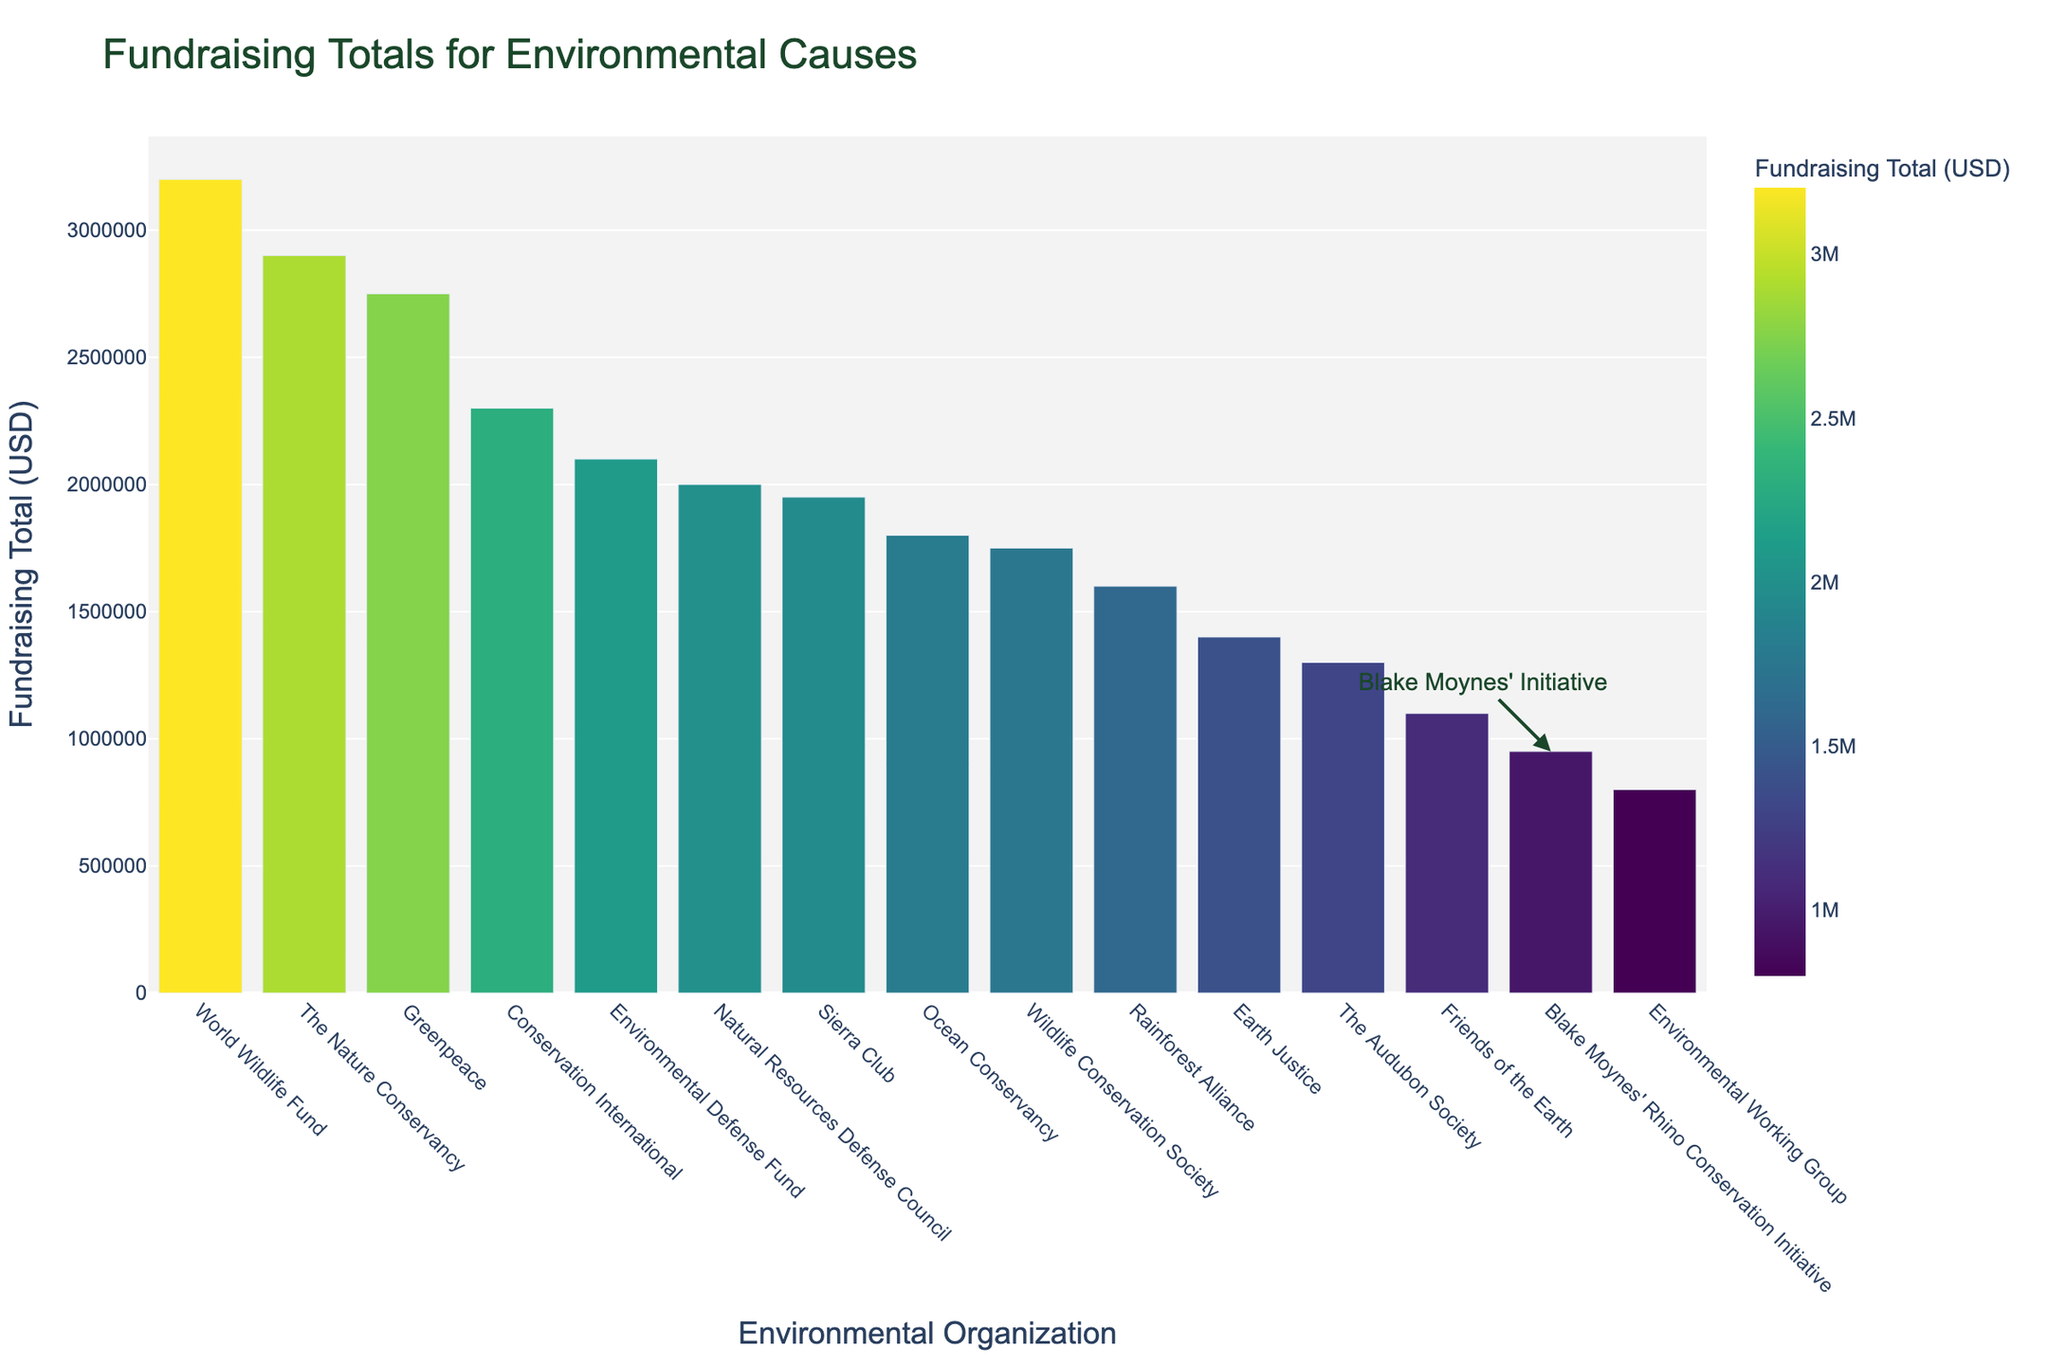Which organization has the highest fundraising total? The highest fundraising total is visually indicated by the tallest bar in the chart. The World Wildlife Fund has the tallest bar.
Answer: World Wildlife Fund Which organization has the lowest fundraising total? The lowest fundraising total is visually indicated by the shortest bar in the chart. The Environmental Working Group has the shortest bar.
Answer: Environmental Working Group What is the total fundraising amount for the top three organizations combined? Sum the fundraising totals of Greenpeace, World Wildlife Fund, and The Nature Conservancy. 2,750,000 + 3,200,000 + 2,900,000 = 8,850,000.
Answer: 8,850,000 How much more did the World Wildlife Fund raise compared to Earth Justice? Subtract Earth Justice’s total from World Wildlife Fund’s total. 3,200,000 - 1,400,000 = 1,800,000.
Answer: 1,800,000 Which organization is just above Blake Moynes' Rhino Conservation Initiative in fundraising totals? Look for the organization that has the next higher bar above Blake Moynes' Rhino Conservation Initiative. Friends of the Earth is just above it.
Answer: Friends of the Earth How much did Conservation International raise compared to the combined total of Ocean Conservancy and Rainforest Alliance? Add Ocean Conservancy and Rainforest Alliance totals, then subtract from Conservation International’s total. (1,800,000 + 1,600,000) = 3,400,000; 2,300,000 - 3,400,000 = -1,100,000.
Answer: -1,100,000 By how much does the fundraising total of The Nature Conservancy exceed Sierra Club's? Subtract Sierra Club's total from The Nature Conservancy’s total. 2,900,000 - 1,950,000 = 950,000.
Answer: 950,000 What is the average fundraising total of the organizations listed? Sum all fundraising totals and divide by the number of organizations. (27,500,000 + 32,000,000 + 29,000,000 + 18,000,000 + 21,000,000 + 19,500,000 + 23,000,000 + 20,000,000 + 16,000,000 + 17,500,000 + 14,000,000 + 13,000,000 + 9,500,000 + 11,000,000 + 8,000,000) / 15 = 292,500,000 / 15 = 19,500,000.
Answer: 1,950,000 Which organization raised approximately double the amount of Friends of the Earth? Find the organization whose total is roughly twice 1,100,000. Sierra Club raised 1,950,000, approximately double.
Answer: Sierra Club Describe the color of the bar representing Greenpeace's fundraising totals. The bar color uses a Viridis scale. The second tallest bar is dark green in color.
Answer: Dark green 